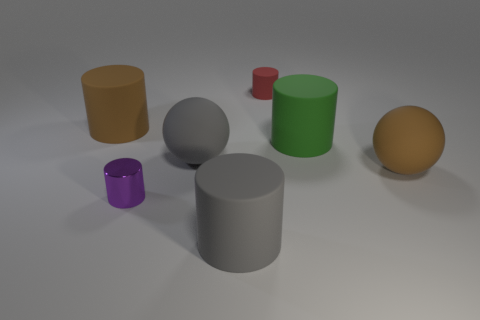What is the material of the purple thing that is the same shape as the big green matte object?
Provide a short and direct response. Metal. What is the material of the purple cylinder left of the big brown object that is on the right side of the large matte sphere that is left of the large green matte cylinder?
Make the answer very short. Metal. The gray cylinder that is made of the same material as the red cylinder is what size?
Your answer should be very brief. Large. Is there any other thing that has the same color as the metallic object?
Give a very brief answer. No. There is a large matte thing behind the large green matte cylinder; is it the same color as the thing on the right side of the big green object?
Your response must be concise. Yes. There is a rubber ball to the left of the red rubber thing; what is its color?
Provide a succinct answer. Gray. Is the size of the gray thing that is behind the purple metallic cylinder the same as the purple cylinder?
Your answer should be compact. No. Are there fewer brown objects than matte objects?
Provide a succinct answer. Yes. How many brown rubber cylinders are to the left of the tiny red object?
Offer a terse response. 1. Is the red object the same shape as the purple metallic thing?
Your response must be concise. Yes. 